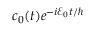<formula> <loc_0><loc_0><loc_500><loc_500>c _ { 0 } ( t ) e ^ { - i \mathcal { E } _ { 0 } t / }</formula> 